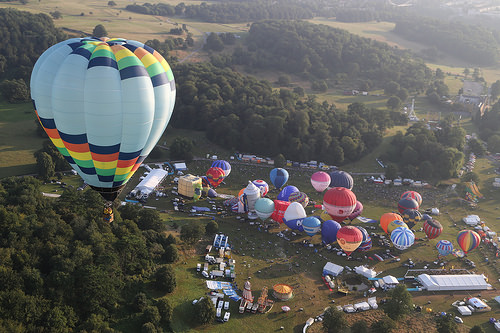<image>
Is the ballon in the sky? Yes. The ballon is contained within or inside the sky, showing a containment relationship. 